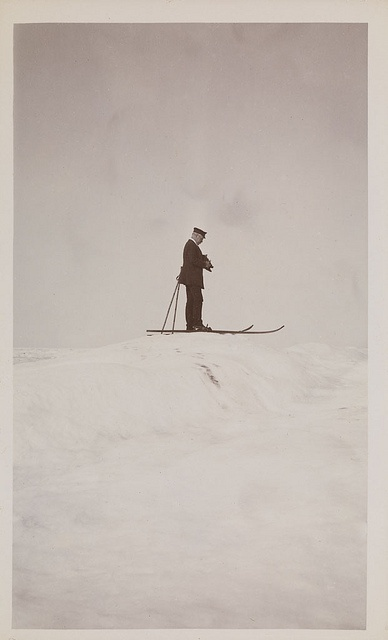Describe the objects in this image and their specific colors. I can see people in tan, maroon, gray, and black tones and skis in tan, black, gray, darkgray, and maroon tones in this image. 